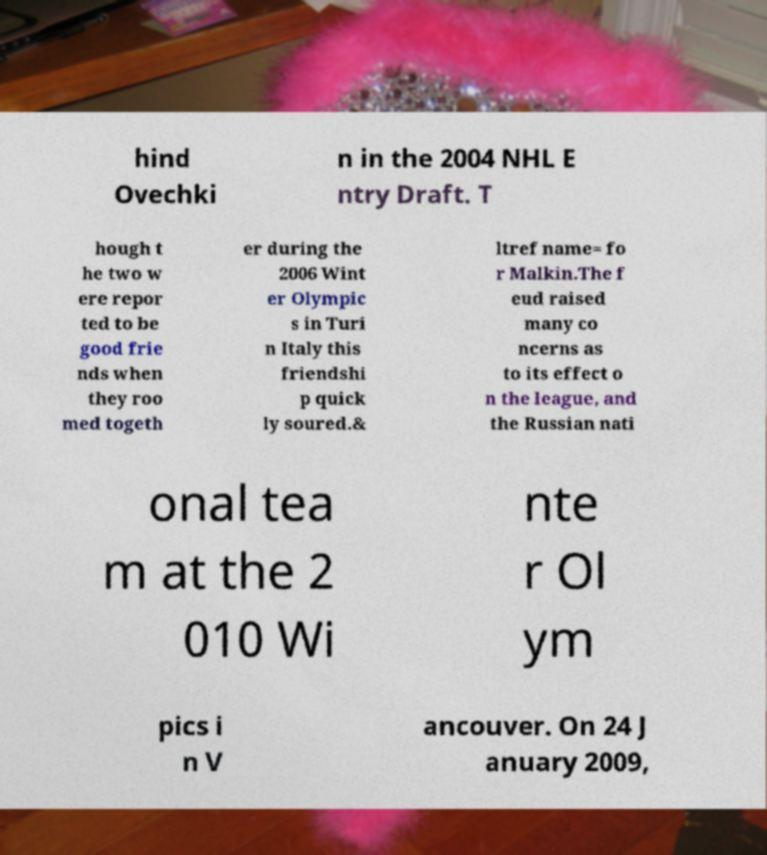I need the written content from this picture converted into text. Can you do that? hind Ovechki n in the 2004 NHL E ntry Draft. T hough t he two w ere repor ted to be good frie nds when they roo med togeth er during the 2006 Wint er Olympic s in Turi n Italy this friendshi p quick ly soured.& ltref name= fo r Malkin.The f eud raised many co ncerns as to its effect o n the league, and the Russian nati onal tea m at the 2 010 Wi nte r Ol ym pics i n V ancouver. On 24 J anuary 2009, 